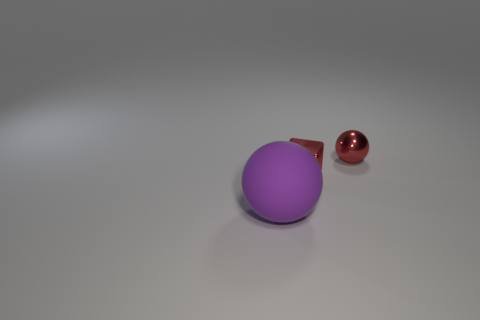Add 2 spheres. How many objects exist? 5 Subtract all spheres. How many objects are left? 1 Subtract 0 gray blocks. How many objects are left? 3 Subtract all large purple shiny things. Subtract all purple matte balls. How many objects are left? 2 Add 1 tiny red spheres. How many tiny red spheres are left? 2 Add 1 large purple shiny spheres. How many large purple shiny spheres exist? 1 